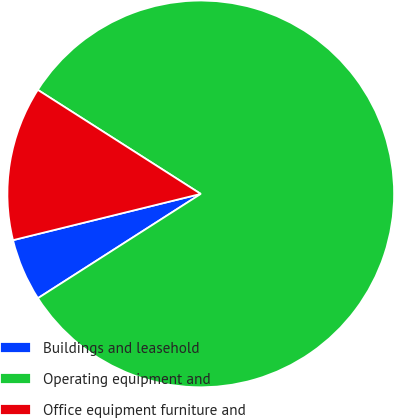<chart> <loc_0><loc_0><loc_500><loc_500><pie_chart><fcel>Buildings and leasehold<fcel>Operating equipment and<fcel>Office equipment furniture and<nl><fcel>5.22%<fcel>81.89%<fcel>12.89%<nl></chart> 